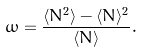Convert formula to latex. <formula><loc_0><loc_0><loc_500><loc_500>\omega = \frac { \langle N ^ { 2 } \rangle - \langle N \rangle ^ { 2 } } { \langle N \rangle } .</formula> 